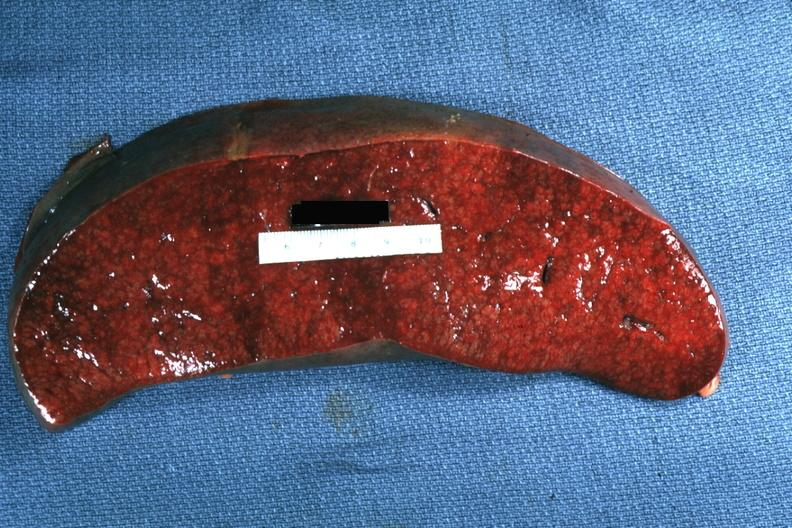s spleen present?
Answer the question using a single word or phrase. Yes 